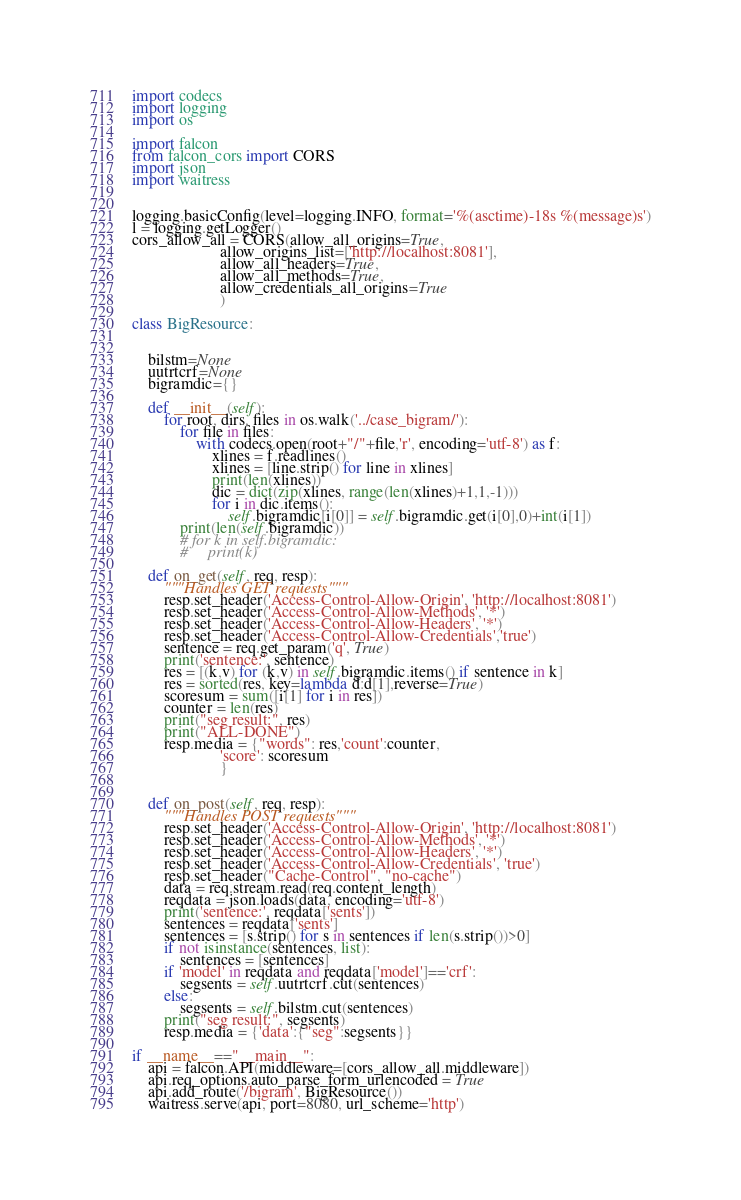<code> <loc_0><loc_0><loc_500><loc_500><_Python_>import codecs
import logging
import os

import falcon
from falcon_cors import CORS
import json
import waitress


logging.basicConfig(level=logging.INFO, format='%(asctime)-18s %(message)s')
l = logging.getLogger()
cors_allow_all = CORS(allow_all_origins=True,
                      allow_origins_list=['http://localhost:8081'],
                      allow_all_headers=True,
                      allow_all_methods=True,
                      allow_credentials_all_origins=True
                      )

class BigResource:


    bilstm=None
    uutrtcrf=None
    bigramdic={}

    def __init__(self):
        for root, dirs, files in os.walk('../case_bigram/'):
            for file in files:
                with codecs.open(root+"/"+file,'r', encoding='utf-8') as f:
                    xlines = f.readlines()
                    xlines = [line.strip() for line in xlines]
                    print(len(xlines))
                    dic = dict(zip(xlines, range(len(xlines)+1,1,-1)))
                    for i in dic.items():
                        self.bigramdic[i[0]] = self.bigramdic.get(i[0],0)+int(i[1])
            print(len(self.bigramdic))
            # for k in self.bigramdic:
            #     print(k)

    def on_get(self, req, resp):
        """Handles GET requests"""
        resp.set_header('Access-Control-Allow-Origin', 'http://localhost:8081')
        resp.set_header('Access-Control-Allow-Methods', '*')
        resp.set_header('Access-Control-Allow-Headers', '*')
        resp.set_header('Access-Control-Allow-Credentials','true')
        sentence = req.get_param('q', True)
        print('sentence:', sentence)
        res = [(k,v) for (k,v) in self.bigramdic.items() if sentence in k]
        res = sorted(res, key=lambda d:d[1],reverse=True)
        scoresum = sum([i[1] for i in res])
        counter = len(res)
        print("seg result:", res)
        print("ALL-DONE")
        resp.media = {"words": res,'count':counter,
                      'score': scoresum
                      }


    def on_post(self, req, resp):
        """Handles POST requests"""
        resp.set_header('Access-Control-Allow-Origin', 'http://localhost:8081')
        resp.set_header('Access-Control-Allow-Methods', '*')
        resp.set_header('Access-Control-Allow-Headers', '*')
        resp.set_header('Access-Control-Allow-Credentials', 'true')
        resp.set_header("Cache-Control", "no-cache")
        data = req.stream.read(req.content_length)
        reqdata = json.loads(data, encoding='utf-8')
        print('sentence:', reqdata['sents'])
        sentences = reqdata['sents']
        sentences = [s.strip() for s in sentences if len(s.strip())>0]
        if not isinstance(sentences, list):
            sentences = [sentences]
        if 'model' in reqdata and reqdata['model']=='crf':
            segsents = self.uutrtcrf.cut(sentences)
        else:
            segsents = self.bilstm.cut(sentences)
        print("seg result:", segsents)
        resp.media = {'data':{"seg":segsents}}

if __name__=="__main__":
    api = falcon.API(middleware=[cors_allow_all.middleware])
    api.req_options.auto_parse_form_urlencoded = True
    api.add_route('/bigram', BigResource())
    waitress.serve(api, port=8080, url_scheme='http')
</code> 